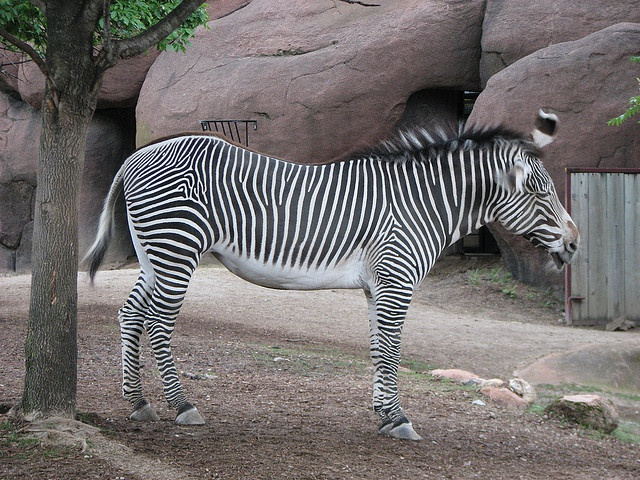Describe the objects in this image and their specific colors. I can see a zebra in darkgreen, black, gray, lightgray, and darkgray tones in this image. 